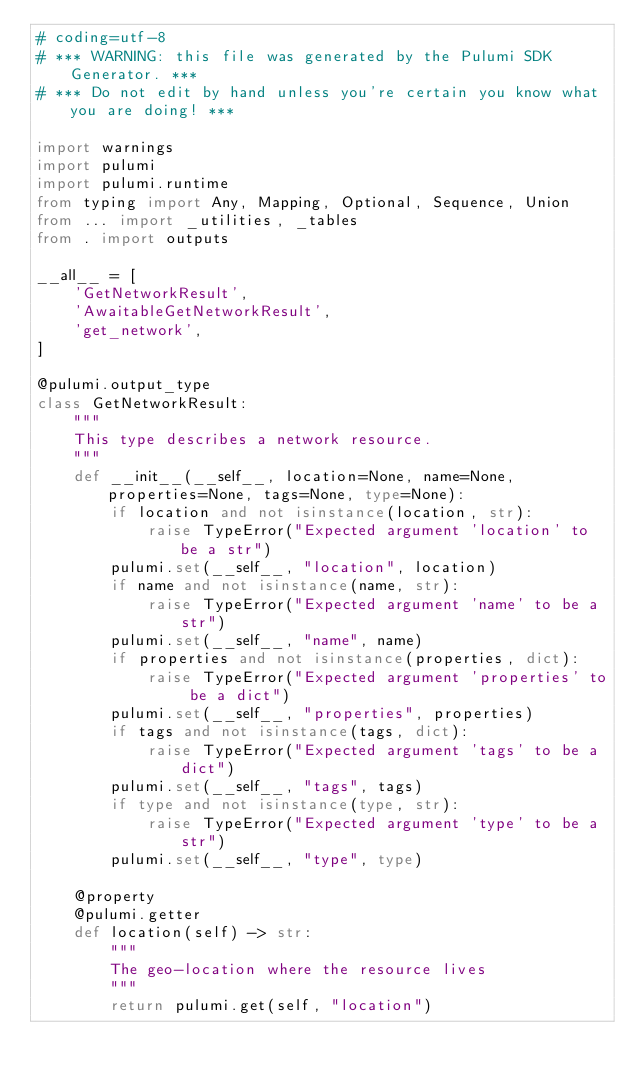Convert code to text. <code><loc_0><loc_0><loc_500><loc_500><_Python_># coding=utf-8
# *** WARNING: this file was generated by the Pulumi SDK Generator. ***
# *** Do not edit by hand unless you're certain you know what you are doing! ***

import warnings
import pulumi
import pulumi.runtime
from typing import Any, Mapping, Optional, Sequence, Union
from ... import _utilities, _tables
from . import outputs

__all__ = [
    'GetNetworkResult',
    'AwaitableGetNetworkResult',
    'get_network',
]

@pulumi.output_type
class GetNetworkResult:
    """
    This type describes a network resource.
    """
    def __init__(__self__, location=None, name=None, properties=None, tags=None, type=None):
        if location and not isinstance(location, str):
            raise TypeError("Expected argument 'location' to be a str")
        pulumi.set(__self__, "location", location)
        if name and not isinstance(name, str):
            raise TypeError("Expected argument 'name' to be a str")
        pulumi.set(__self__, "name", name)
        if properties and not isinstance(properties, dict):
            raise TypeError("Expected argument 'properties' to be a dict")
        pulumi.set(__self__, "properties", properties)
        if tags and not isinstance(tags, dict):
            raise TypeError("Expected argument 'tags' to be a dict")
        pulumi.set(__self__, "tags", tags)
        if type and not isinstance(type, str):
            raise TypeError("Expected argument 'type' to be a str")
        pulumi.set(__self__, "type", type)

    @property
    @pulumi.getter
    def location(self) -> str:
        """
        The geo-location where the resource lives
        """
        return pulumi.get(self, "location")
</code> 